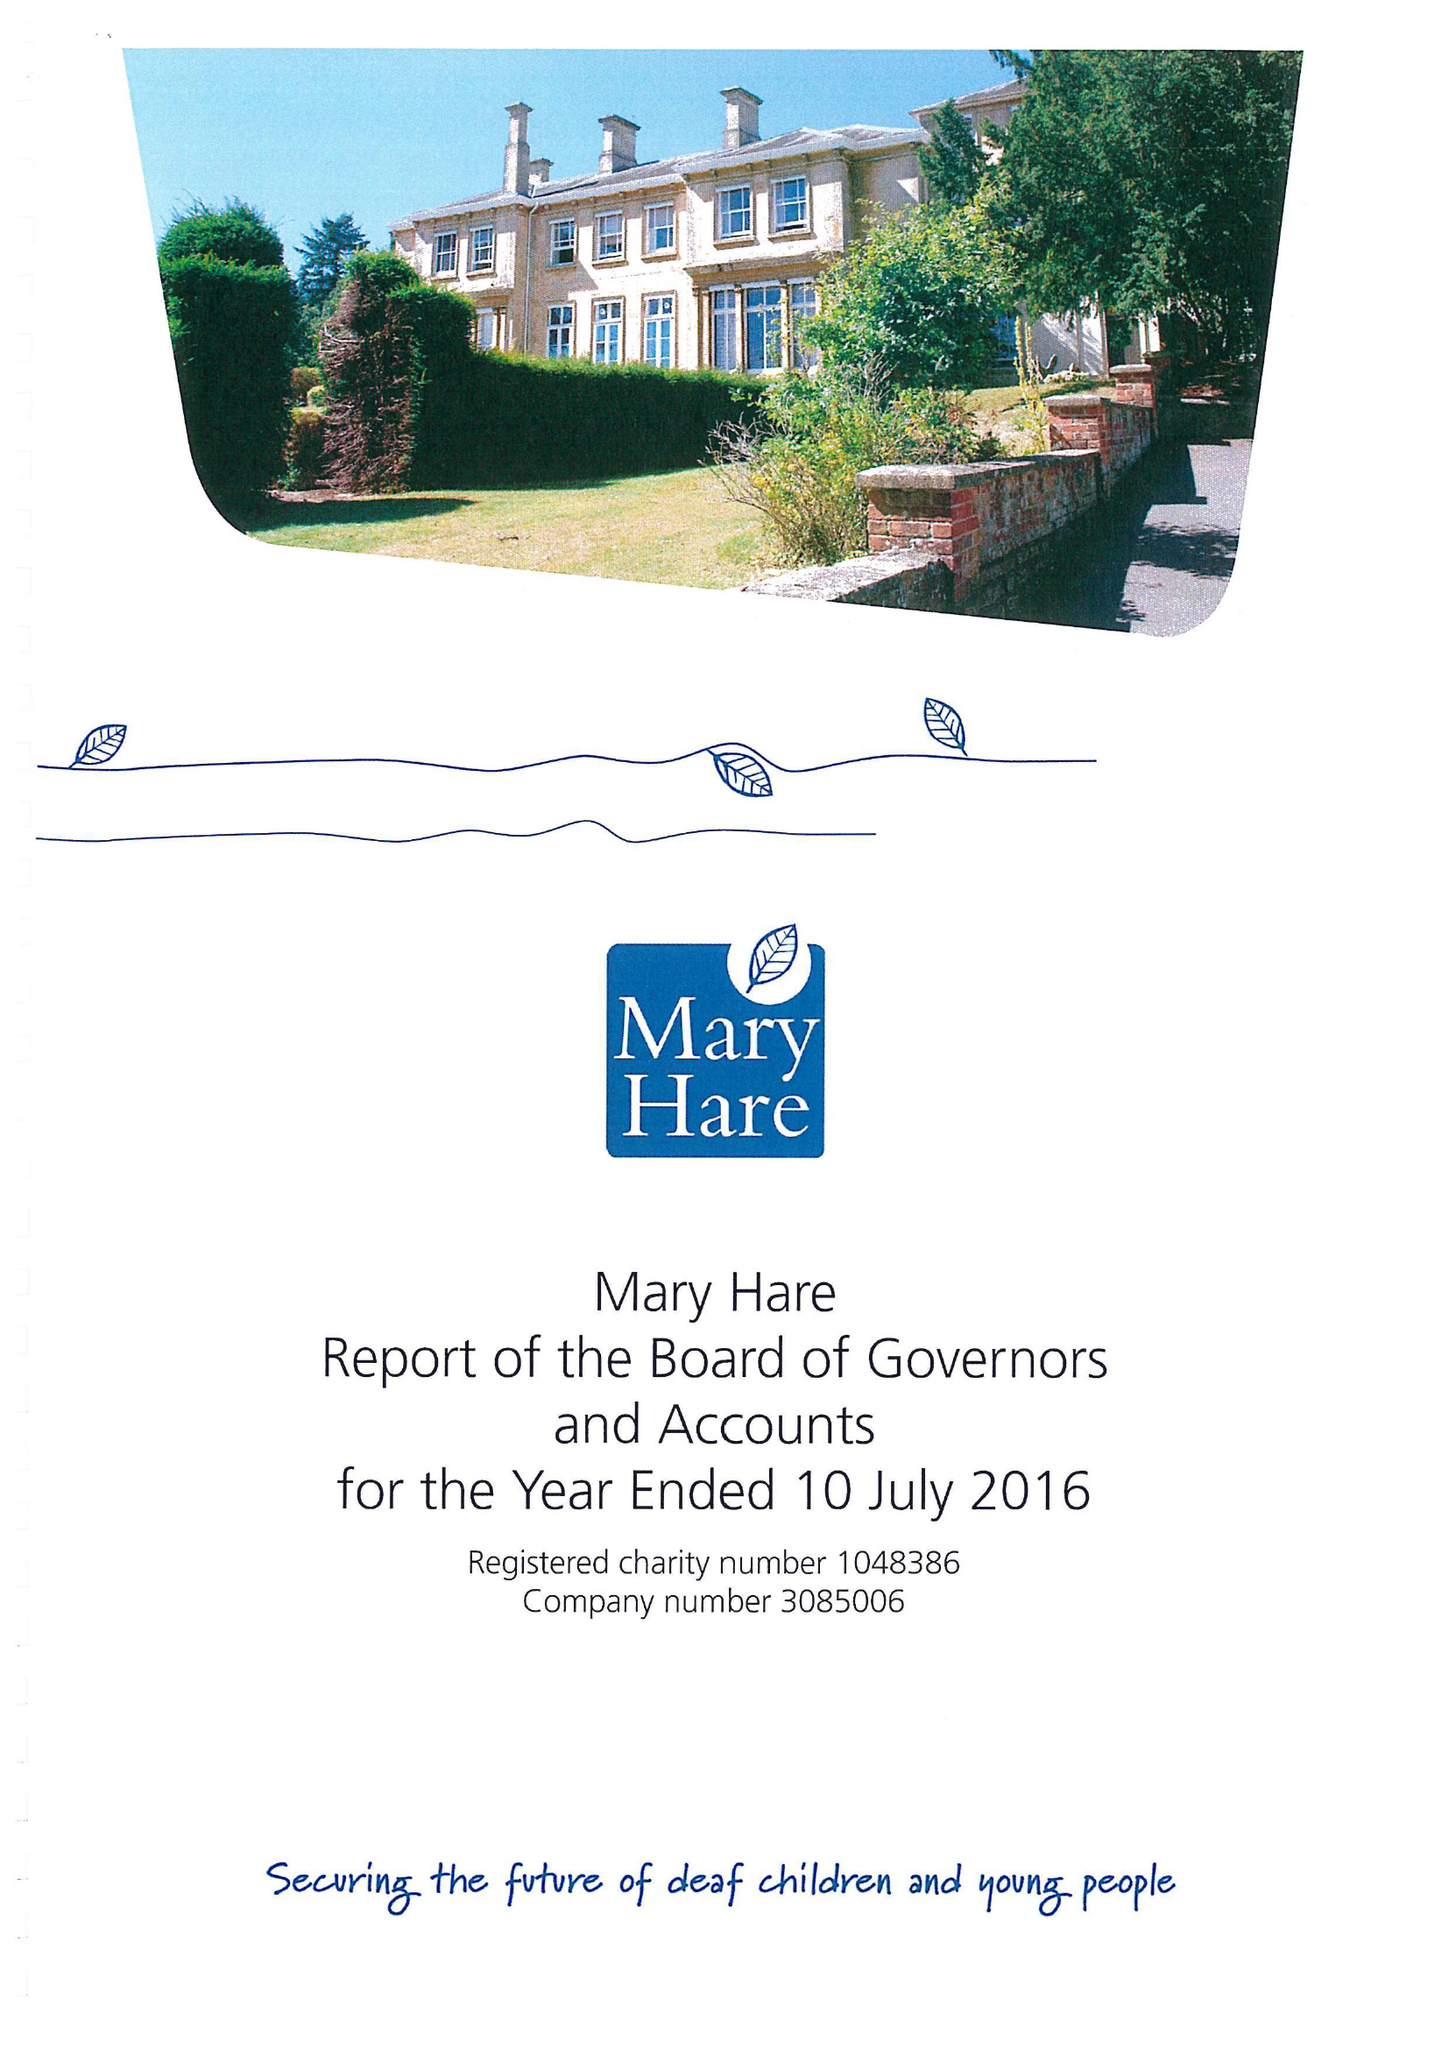What is the value for the report_date?
Answer the question using a single word or phrase. 2016-07-10 